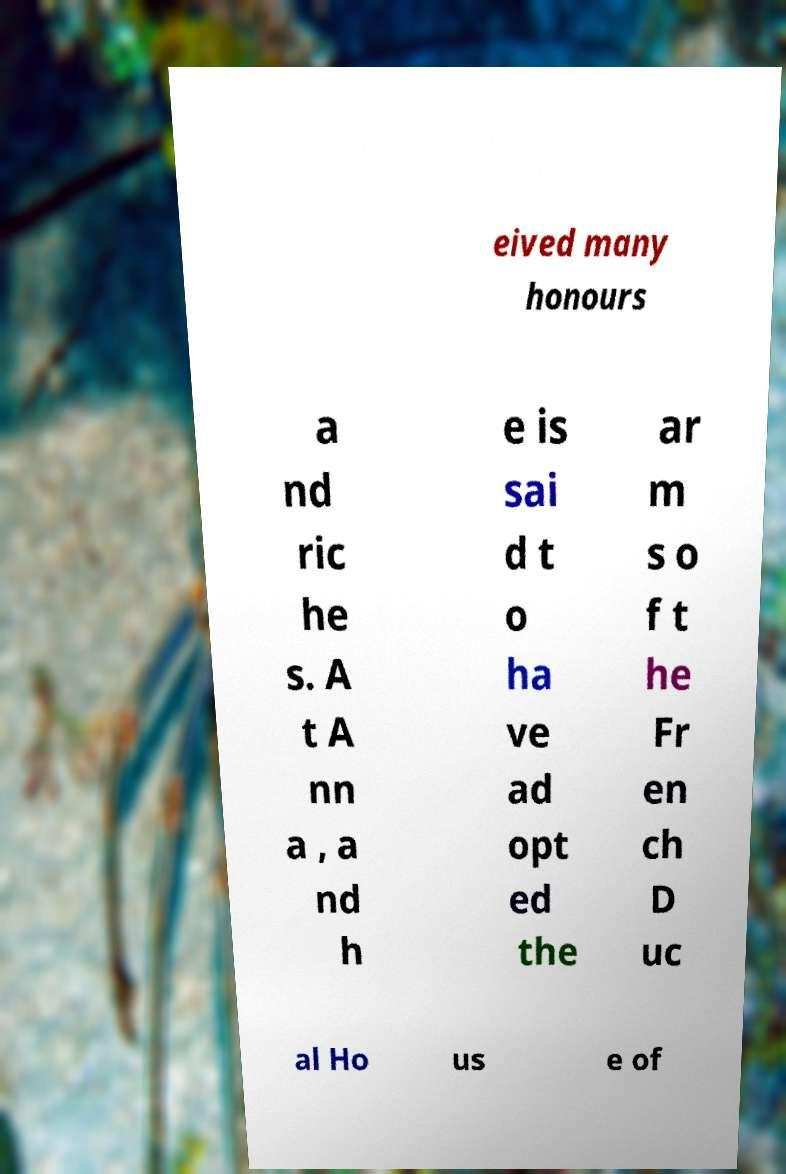There's text embedded in this image that I need extracted. Can you transcribe it verbatim? eived many honours a nd ric he s. A t A nn a , a nd h e is sai d t o ha ve ad opt ed the ar m s o f t he Fr en ch D uc al Ho us e of 